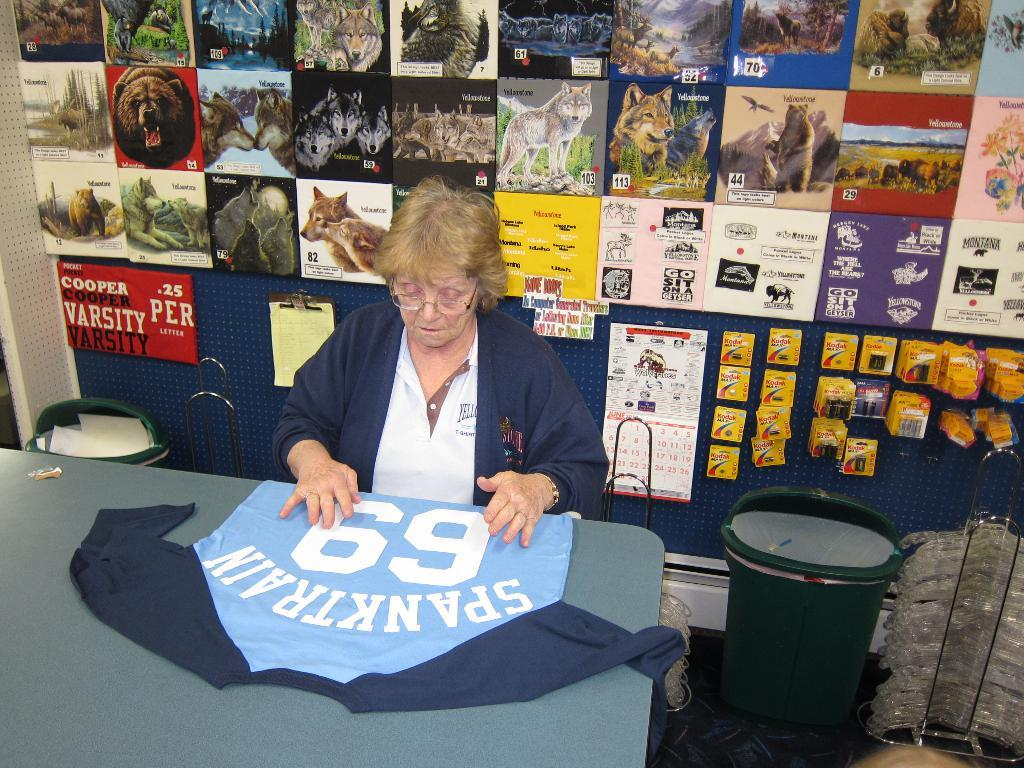Provide a one-sentence caption for the provided image. A woman at a table has a sexual worded shirt in front of her. 